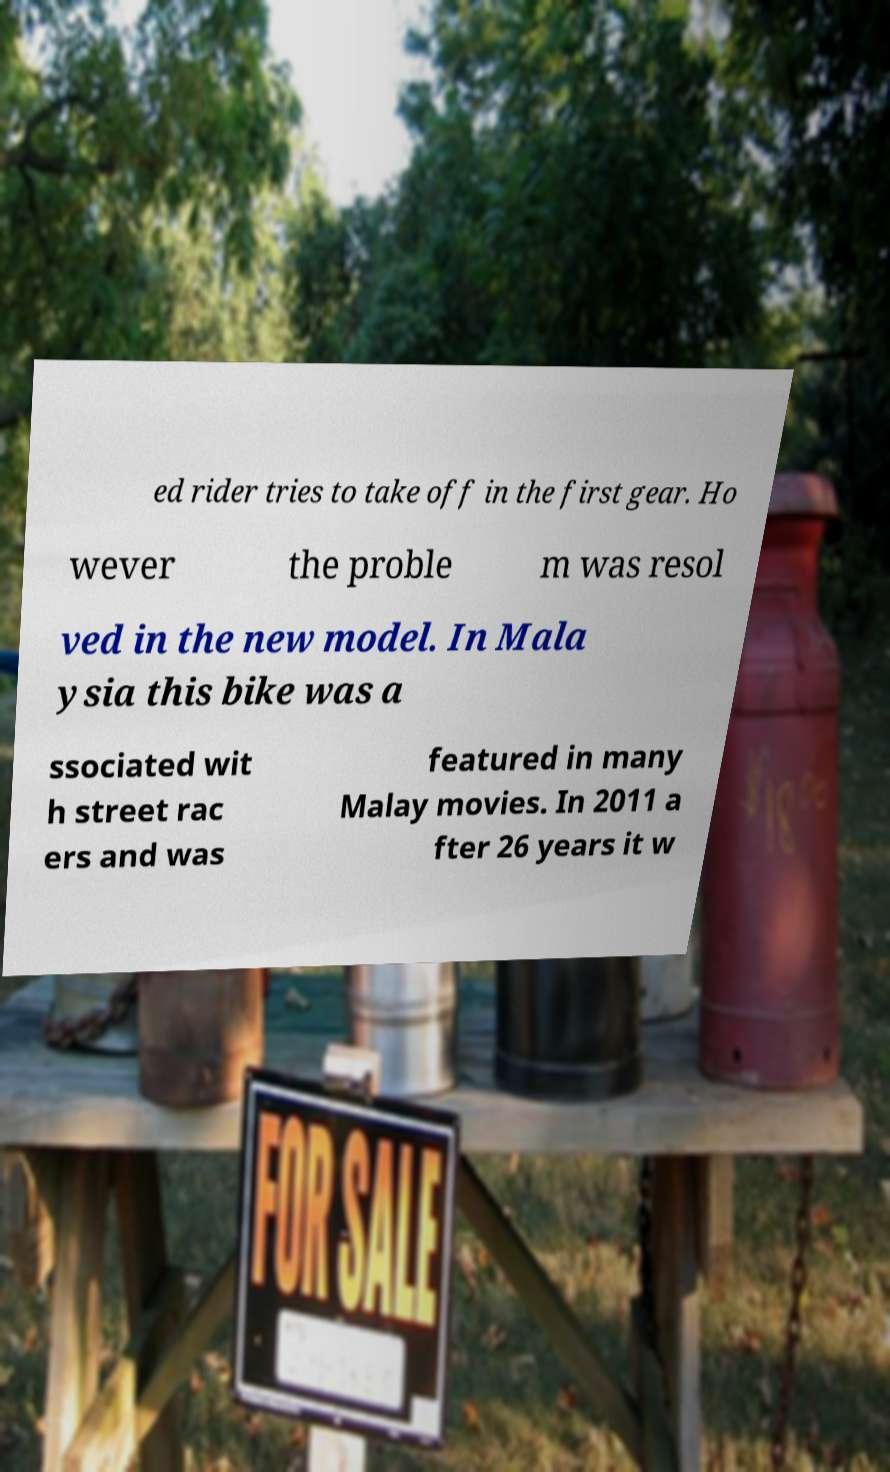Could you assist in decoding the text presented in this image and type it out clearly? ed rider tries to take off in the first gear. Ho wever the proble m was resol ved in the new model. In Mala ysia this bike was a ssociated wit h street rac ers and was featured in many Malay movies. In 2011 a fter 26 years it w 